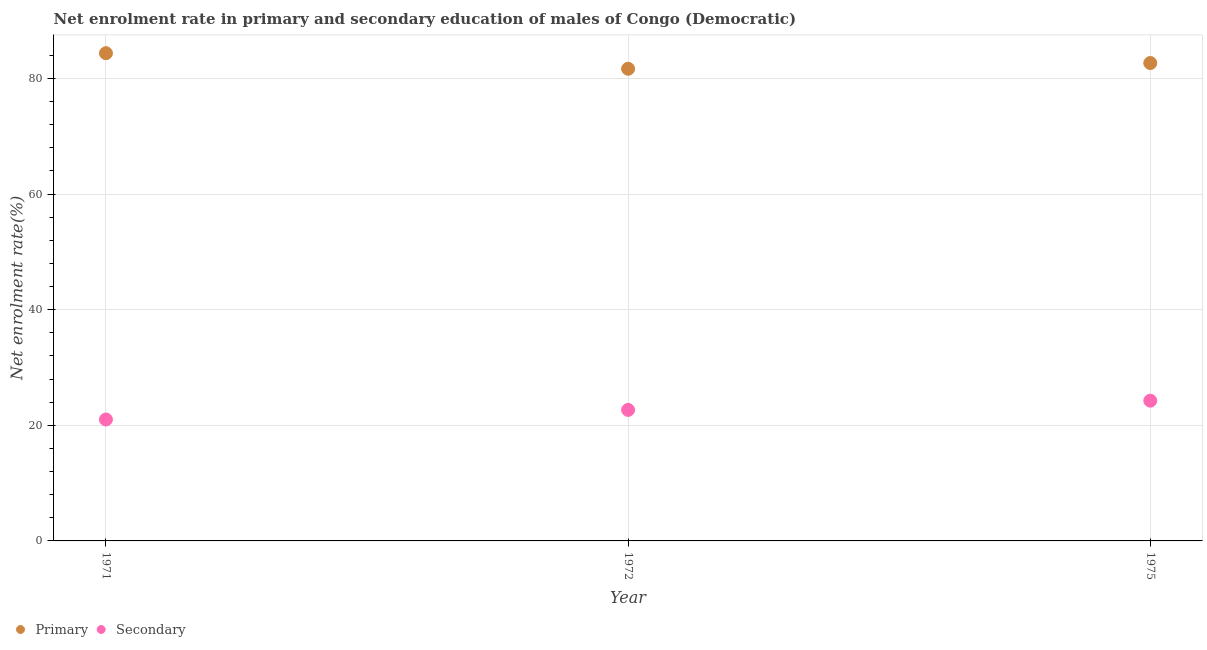How many different coloured dotlines are there?
Offer a very short reply. 2. Is the number of dotlines equal to the number of legend labels?
Your response must be concise. Yes. What is the enrollment rate in secondary education in 1971?
Give a very brief answer. 21. Across all years, what is the maximum enrollment rate in secondary education?
Provide a short and direct response. 24.25. Across all years, what is the minimum enrollment rate in secondary education?
Provide a short and direct response. 21. In which year was the enrollment rate in primary education maximum?
Give a very brief answer. 1971. What is the total enrollment rate in primary education in the graph?
Provide a short and direct response. 248.67. What is the difference between the enrollment rate in secondary education in 1972 and that in 1975?
Your response must be concise. -1.59. What is the difference between the enrollment rate in primary education in 1975 and the enrollment rate in secondary education in 1972?
Offer a terse response. 59.99. What is the average enrollment rate in primary education per year?
Keep it short and to the point. 82.89. In the year 1971, what is the difference between the enrollment rate in secondary education and enrollment rate in primary education?
Your response must be concise. -63.35. What is the ratio of the enrollment rate in primary education in 1971 to that in 1972?
Offer a very short reply. 1.03. Is the difference between the enrollment rate in primary education in 1971 and 1972 greater than the difference between the enrollment rate in secondary education in 1971 and 1972?
Provide a succinct answer. Yes. What is the difference between the highest and the second highest enrollment rate in secondary education?
Make the answer very short. 1.59. What is the difference between the highest and the lowest enrollment rate in secondary education?
Provide a short and direct response. 3.25. Is the sum of the enrollment rate in primary education in 1971 and 1972 greater than the maximum enrollment rate in secondary education across all years?
Ensure brevity in your answer.  Yes. Does the graph contain any zero values?
Ensure brevity in your answer.  No. How many legend labels are there?
Give a very brief answer. 2. What is the title of the graph?
Your answer should be very brief. Net enrolment rate in primary and secondary education of males of Congo (Democratic). Does "Measles" appear as one of the legend labels in the graph?
Your response must be concise. No. What is the label or title of the X-axis?
Provide a succinct answer. Year. What is the label or title of the Y-axis?
Make the answer very short. Net enrolment rate(%). What is the Net enrolment rate(%) in Primary in 1971?
Your response must be concise. 84.35. What is the Net enrolment rate(%) in Secondary in 1971?
Give a very brief answer. 21. What is the Net enrolment rate(%) in Primary in 1972?
Make the answer very short. 81.66. What is the Net enrolment rate(%) in Secondary in 1972?
Your answer should be compact. 22.66. What is the Net enrolment rate(%) in Primary in 1975?
Offer a very short reply. 82.65. What is the Net enrolment rate(%) in Secondary in 1975?
Give a very brief answer. 24.25. Across all years, what is the maximum Net enrolment rate(%) in Primary?
Ensure brevity in your answer.  84.35. Across all years, what is the maximum Net enrolment rate(%) of Secondary?
Provide a succinct answer. 24.25. Across all years, what is the minimum Net enrolment rate(%) in Primary?
Ensure brevity in your answer.  81.66. Across all years, what is the minimum Net enrolment rate(%) in Secondary?
Provide a short and direct response. 21. What is the total Net enrolment rate(%) of Primary in the graph?
Offer a very short reply. 248.67. What is the total Net enrolment rate(%) in Secondary in the graph?
Provide a short and direct response. 67.92. What is the difference between the Net enrolment rate(%) in Primary in 1971 and that in 1972?
Provide a short and direct response. 2.69. What is the difference between the Net enrolment rate(%) in Secondary in 1971 and that in 1972?
Make the answer very short. -1.66. What is the difference between the Net enrolment rate(%) in Primary in 1971 and that in 1975?
Offer a terse response. 1.7. What is the difference between the Net enrolment rate(%) of Secondary in 1971 and that in 1975?
Your answer should be very brief. -3.25. What is the difference between the Net enrolment rate(%) of Primary in 1972 and that in 1975?
Ensure brevity in your answer.  -0.99. What is the difference between the Net enrolment rate(%) in Secondary in 1972 and that in 1975?
Your answer should be very brief. -1.59. What is the difference between the Net enrolment rate(%) of Primary in 1971 and the Net enrolment rate(%) of Secondary in 1972?
Keep it short and to the point. 61.69. What is the difference between the Net enrolment rate(%) of Primary in 1971 and the Net enrolment rate(%) of Secondary in 1975?
Give a very brief answer. 60.1. What is the difference between the Net enrolment rate(%) of Primary in 1972 and the Net enrolment rate(%) of Secondary in 1975?
Offer a terse response. 57.41. What is the average Net enrolment rate(%) of Primary per year?
Your answer should be very brief. 82.89. What is the average Net enrolment rate(%) of Secondary per year?
Offer a terse response. 22.64. In the year 1971, what is the difference between the Net enrolment rate(%) of Primary and Net enrolment rate(%) of Secondary?
Ensure brevity in your answer.  63.35. In the year 1972, what is the difference between the Net enrolment rate(%) in Primary and Net enrolment rate(%) in Secondary?
Give a very brief answer. 59. In the year 1975, what is the difference between the Net enrolment rate(%) in Primary and Net enrolment rate(%) in Secondary?
Offer a terse response. 58.4. What is the ratio of the Net enrolment rate(%) in Primary in 1971 to that in 1972?
Provide a short and direct response. 1.03. What is the ratio of the Net enrolment rate(%) in Secondary in 1971 to that in 1972?
Your response must be concise. 0.93. What is the ratio of the Net enrolment rate(%) of Primary in 1971 to that in 1975?
Your answer should be compact. 1.02. What is the ratio of the Net enrolment rate(%) of Secondary in 1971 to that in 1975?
Give a very brief answer. 0.87. What is the ratio of the Net enrolment rate(%) of Primary in 1972 to that in 1975?
Ensure brevity in your answer.  0.99. What is the ratio of the Net enrolment rate(%) of Secondary in 1972 to that in 1975?
Your answer should be compact. 0.93. What is the difference between the highest and the second highest Net enrolment rate(%) of Primary?
Offer a very short reply. 1.7. What is the difference between the highest and the second highest Net enrolment rate(%) of Secondary?
Offer a terse response. 1.59. What is the difference between the highest and the lowest Net enrolment rate(%) in Primary?
Make the answer very short. 2.69. What is the difference between the highest and the lowest Net enrolment rate(%) of Secondary?
Make the answer very short. 3.25. 